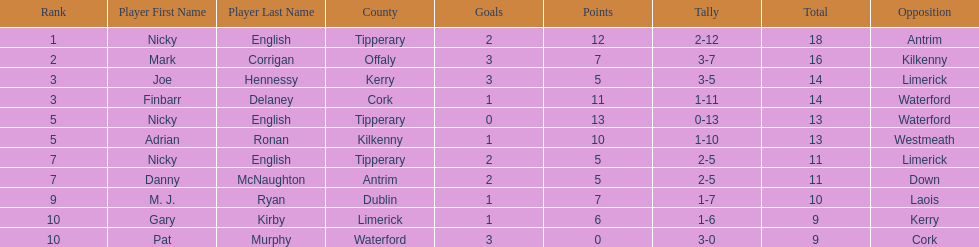Joe hennessy and finbarr delaney both scored how many points? 14. 